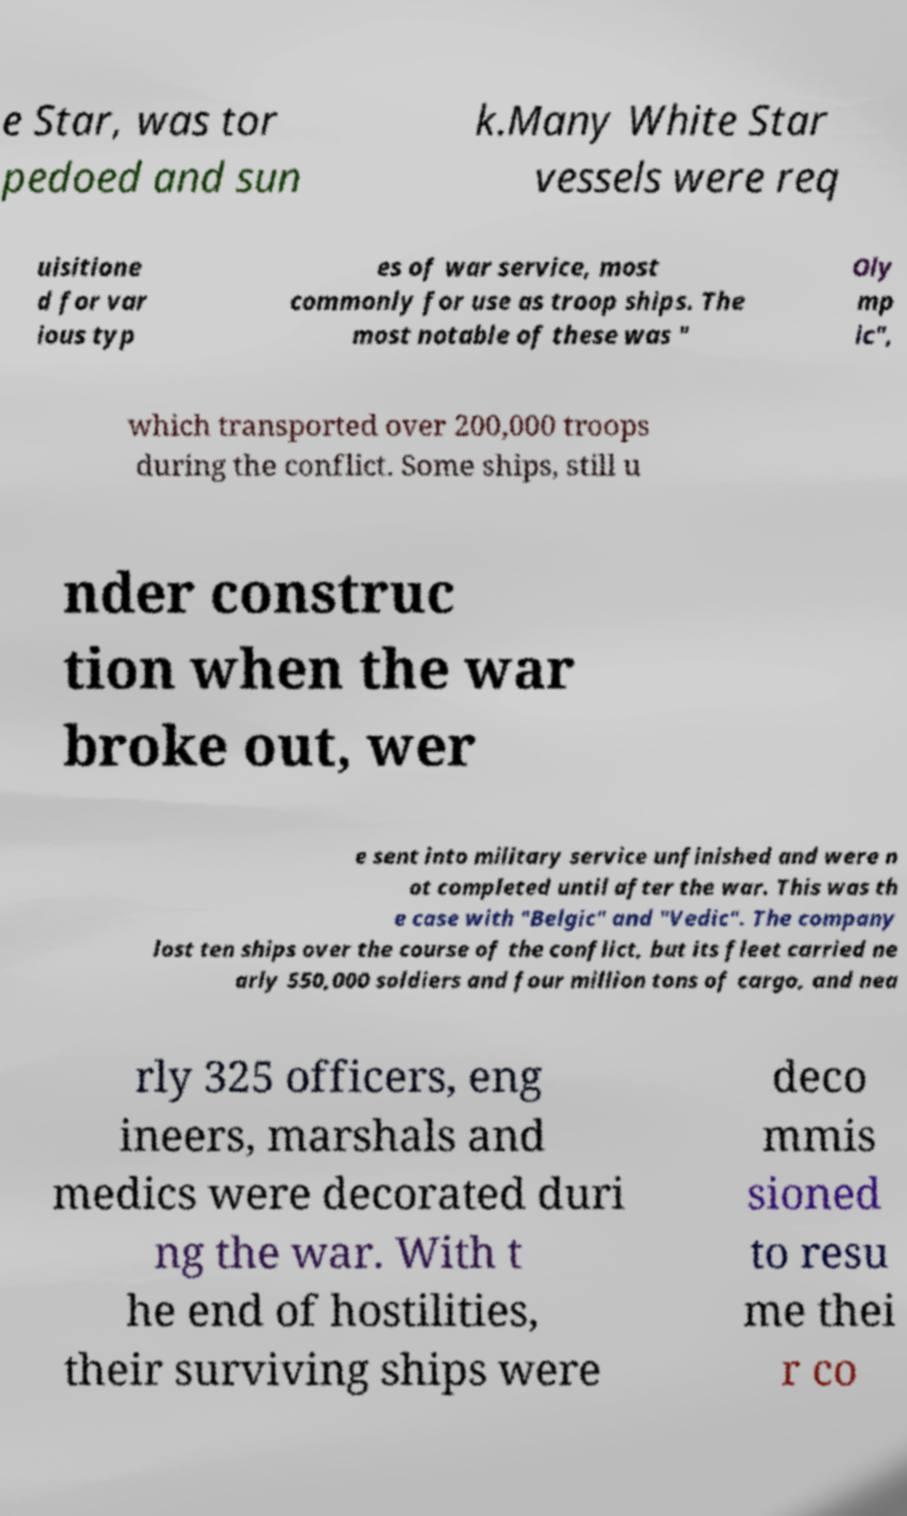Please read and relay the text visible in this image. What does it say? e Star, was tor pedoed and sun k.Many White Star vessels were req uisitione d for var ious typ es of war service, most commonly for use as troop ships. The most notable of these was " Oly mp ic", which transported over 200,000 troops during the conflict. Some ships, still u nder construc tion when the war broke out, wer e sent into military service unfinished and were n ot completed until after the war. This was th e case with "Belgic" and "Vedic". The company lost ten ships over the course of the conflict, but its fleet carried ne arly 550,000 soldiers and four million tons of cargo, and nea rly 325 officers, eng ineers, marshals and medics were decorated duri ng the war. With t he end of hostilities, their surviving ships were deco mmis sioned to resu me thei r co 